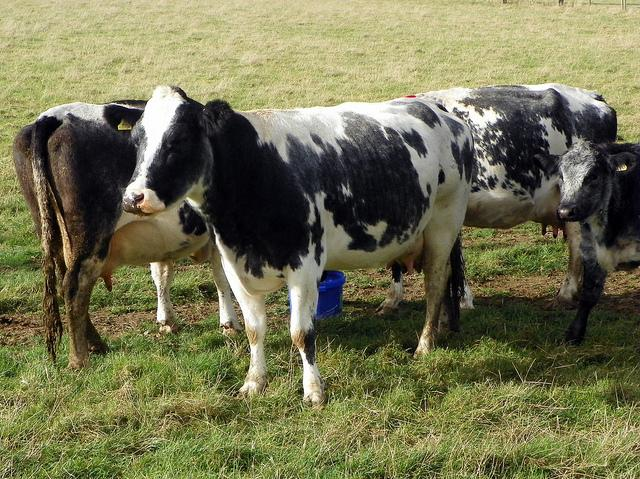Which animal look different than the cows in the picture? Please explain your reasoning. goat. There are several cows with one goat in the bunch. 